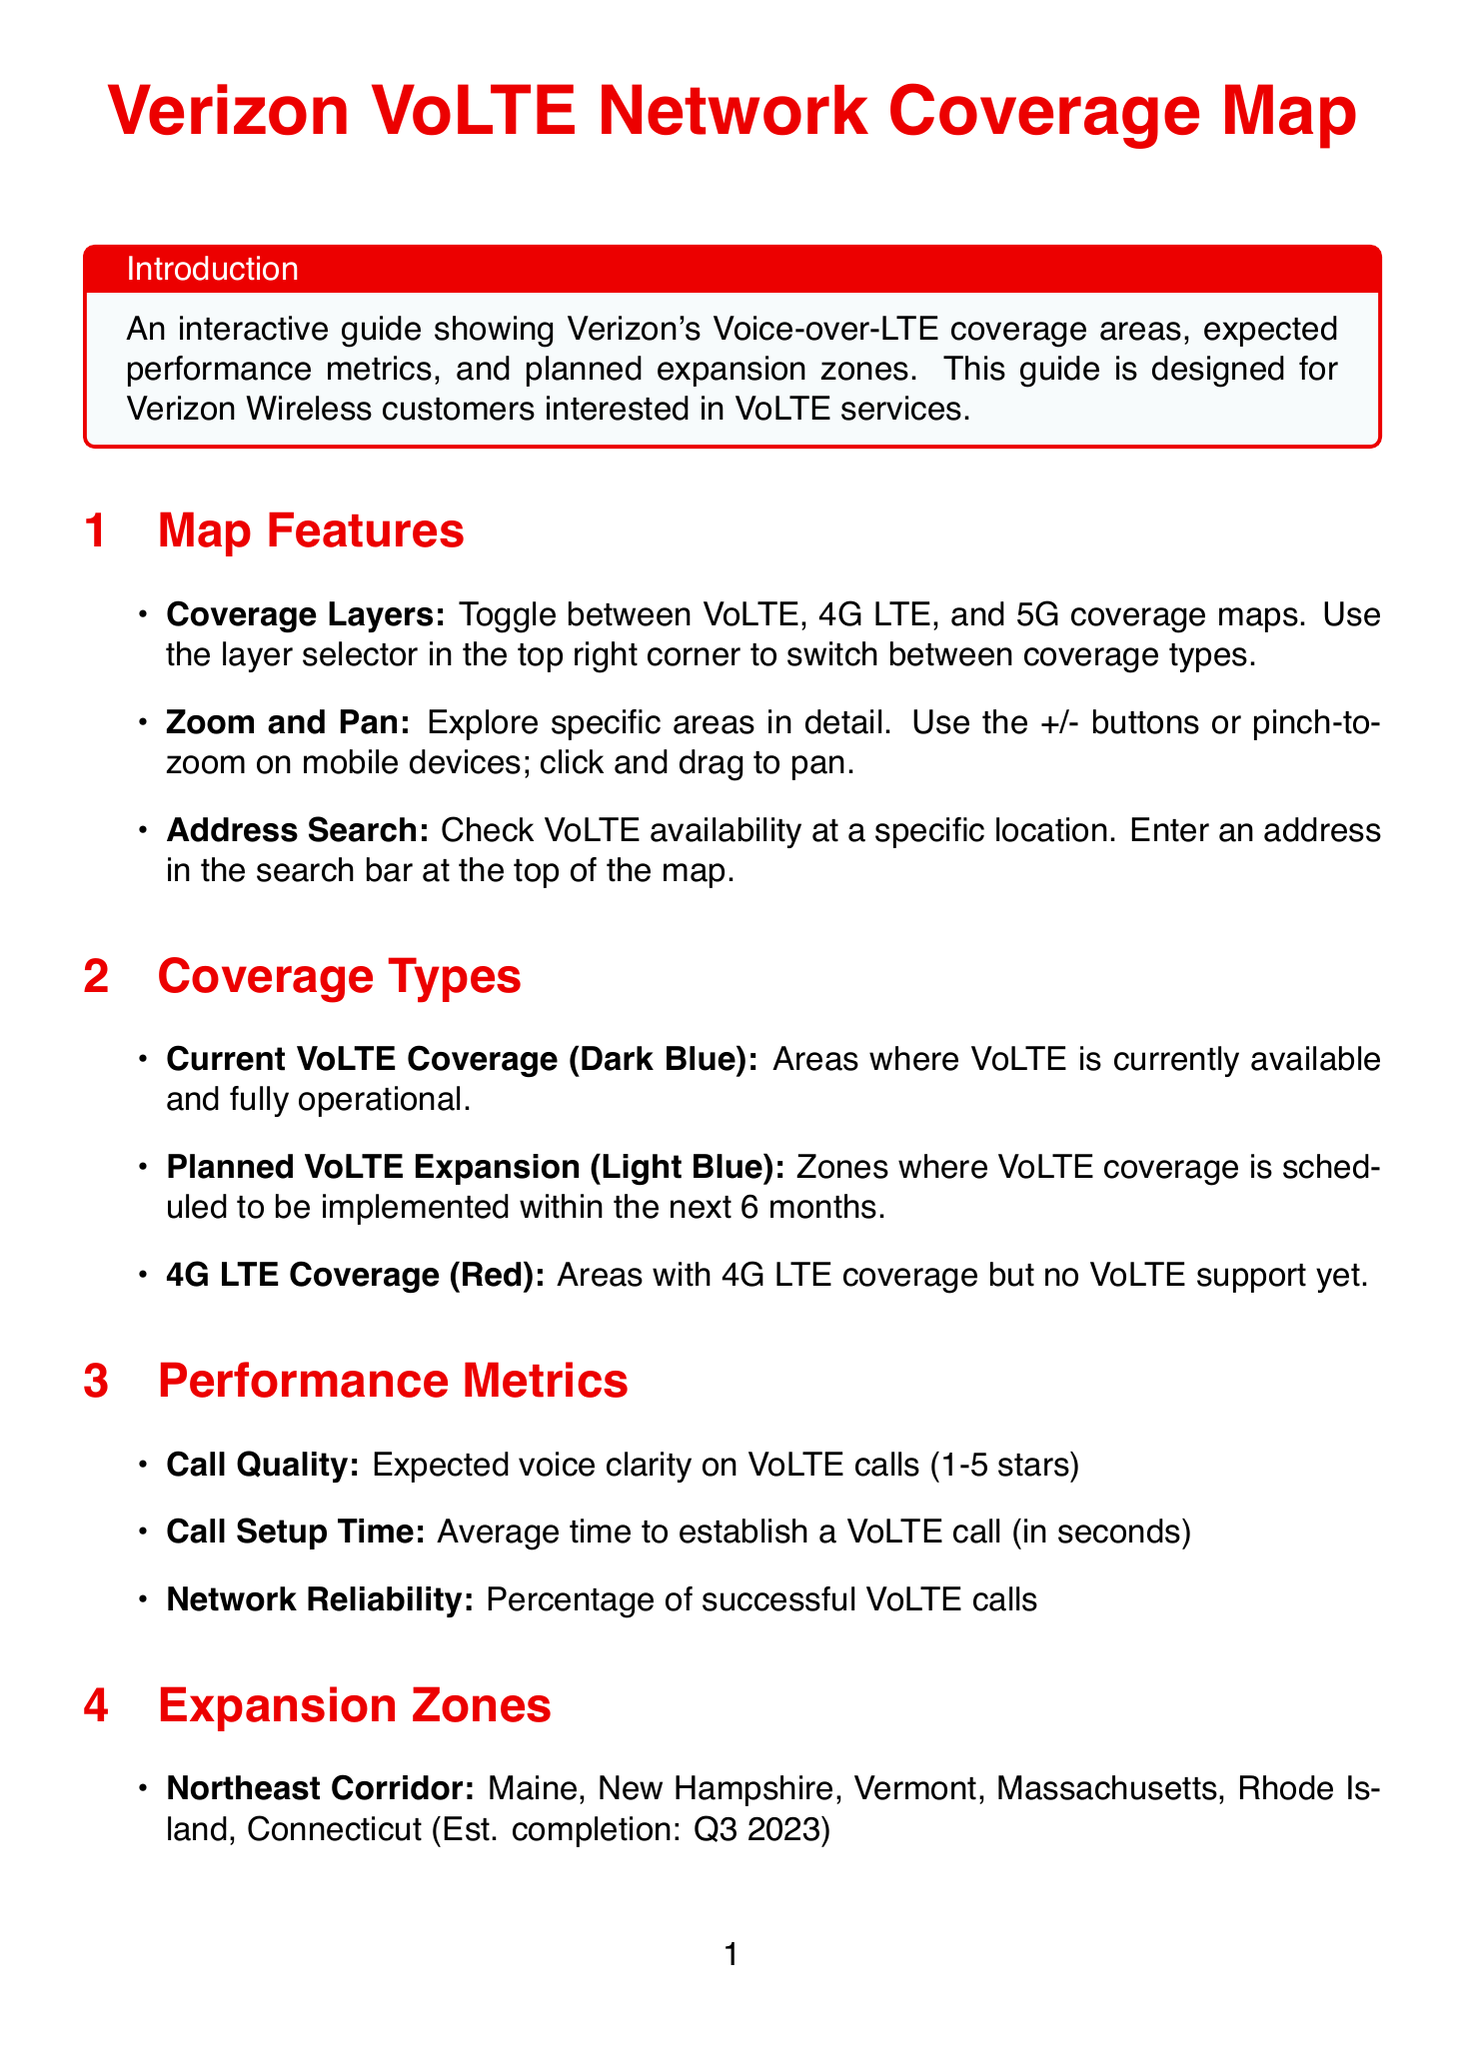What is the title of the document? The title is found in the introduction section of the document.
Answer: Verizon VoLTE Network Coverage Map What color represents current VoLTE coverage? The color coding for different coverage types is detailed in the coverage types section.
Answer: Dark Blue Which states are included in the Northeast Corridor expansion zone? The states are listed under the expansion zones section.
Answer: Maine, New Hampshire, Vermont, Massachusetts, Rhode Island, Connecticut How many stars is the call quality metric measured on? The number of stars for the call quality metric is mentioned in the performance metrics section.
Answer: 1-5 stars What is the estimated completion for Southern California expansion? The estimated completion dates for various zones are provided in the expansion zones section.
Answer: Q2 2024 What should you check if VoLTE is not working? Steps to troubleshoot VoLTE issues are outlined in the troubleshooting section.
Answer: Device compatibility Is VoLTE included in the existing Verizon voice plan at extra charge? This is addressed in the FAQs section.
Answer: No Which devices are popular for VoLTE support? Popular devices supporting VoLTE are listed under the device compatibility section.
Answer: iPhone 12, iPhone 13, Samsung Galaxy S21, Samsung Galaxy S22, Google Pixel 6, Google Pixel 7 What can customers expect to improve with VoLTE? The benefits of VoLTE are laid out in the customer benefits section.
Answer: Improved call quality with HD Voice 